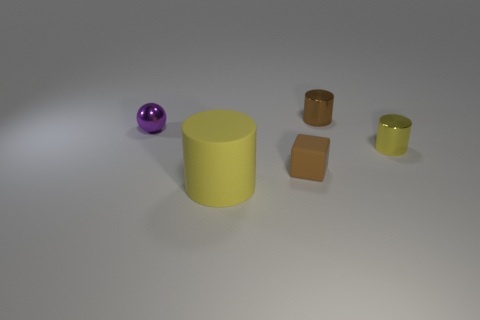How many things are tiny things to the right of the small brown shiny cylinder or tiny objects that are on the right side of the brown cube?
Your answer should be compact. 2. What number of other things are there of the same shape as the big object?
Make the answer very short. 2. Is the color of the metallic object to the left of the big yellow thing the same as the small cube?
Offer a very short reply. No. How many other objects are there of the same size as the brown cylinder?
Your response must be concise. 3. Does the tiny cube have the same material as the big thing?
Offer a terse response. Yes. There is a metallic cylinder that is behind the tiny shiny cylinder that is right of the brown cylinder; what color is it?
Your answer should be compact. Brown. There is a yellow metal object that is the same shape as the yellow rubber thing; what is its size?
Your response must be concise. Small. Is the big object the same color as the small ball?
Make the answer very short. No. What number of small brown objects are behind the brown object in front of the metallic cylinder to the right of the brown cylinder?
Ensure brevity in your answer.  1. Is the number of brown cubes greater than the number of tiny shiny cylinders?
Offer a terse response. No. 